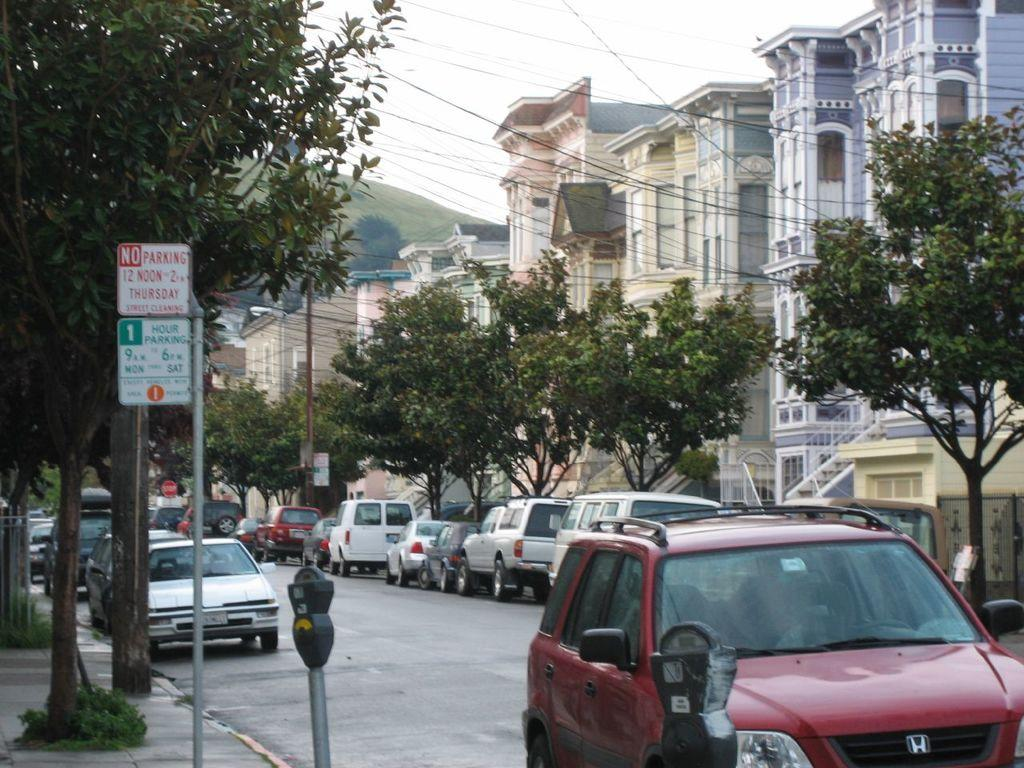What types of objects can be seen in the image? There are vehicles, trees, signboards, poles, buildings, windows, a parking meter, and a light pole in the image. What is the color of the sky in the image? The sky is white in color. What might be used to regulate parking in the image? There is a parking meter in the image. What can be seen on the buildings in the image? Windows are visible on the buildings in the image. How many children are playing in the rain in the image? There are no children or rain present in the image. What type of town is depicted in the image? The image does not depict a town; it shows a collection of objects and features, including vehicles, trees, signboards, poles, buildings, windows, a parking meter, and a light pole. 